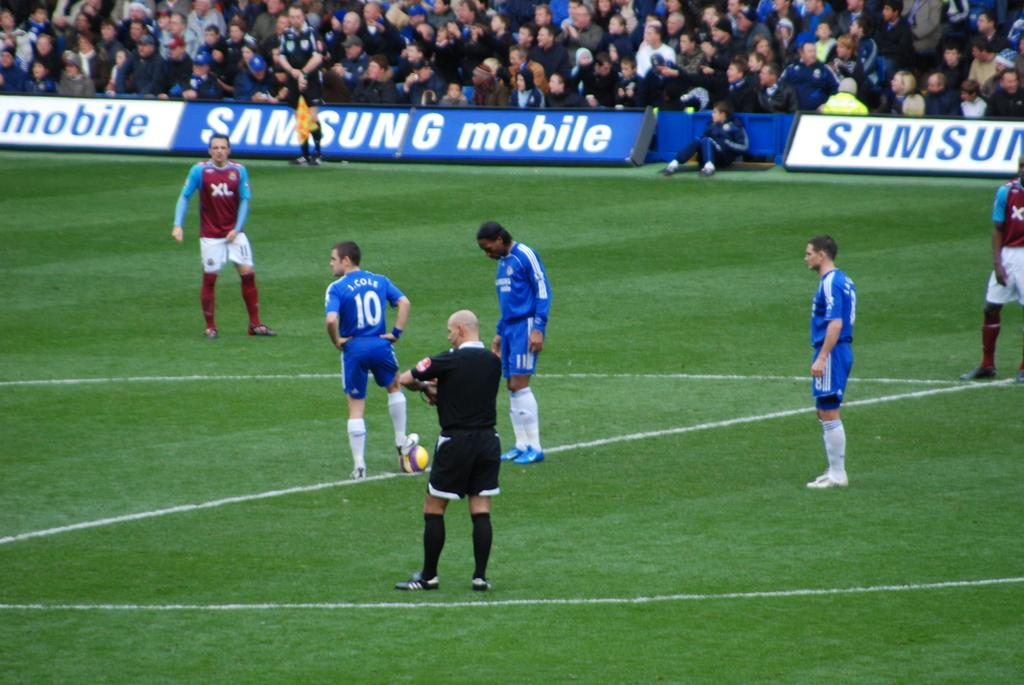<image>
Offer a succinct explanation of the picture presented. A soccer game is going on in a Samsung mobile stadium with lots of spectators. 